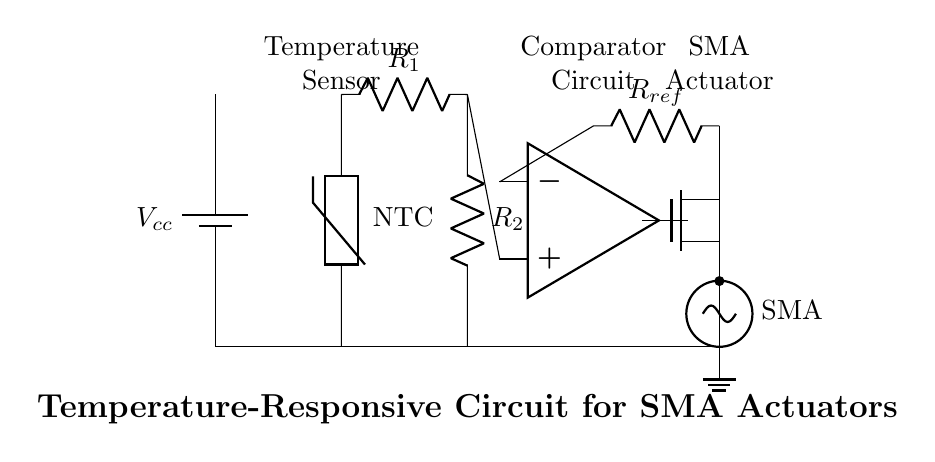What type of temperature sensor is used? The circuit uses an NTC thermistor, identified by the label next to the component, which indicates it has a negative temperature coefficient.
Answer: NTC thermistor What is the role of the op-amp in this circuit? The op-amp acts as a comparator that compares the voltage from the resistor divider to a reference voltage, determining whether to activate the SMA actuator.
Answer: Comparator What component provides the power supply? The battery, indicated in the circuit, provides the necessary voltage for the entire circuit operation.
Answer: Battery What type of actuator is being used in this circuit? The actuator is a shape memory alloy (SMA) actuator, which is mentioned directly in the circuit diagram label next to the corresponding symbol.
Answer: SMA actuator What is the function of the resistor labeled R1? Resistor R1 is part of a voltage divider with R2, affecting the voltage input to the op-amp comparator based on the temperature detected by the thermistor.
Answer: Voltage divider What happens if the temperature exceeds the reference voltage? If the temperature exceeds the reference voltage, the output from the op-amp will activate the MOSFET, which in turn powers the SMA actuator to respond to the increased temperature.
Answer: Activate the SMA actuator How many resistors are present in the circuit? There are two resistors in the circuit, labeled as R1 and R2, which are part of the resistor divider configuration.
Answer: Two resistors 